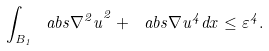<formula> <loc_0><loc_0><loc_500><loc_500>\int _ { B _ { 1 } } \ a b s { \nabla ^ { 2 } u } ^ { 2 } + \ a b s { \nabla u } ^ { 4 } d x \leq \varepsilon ^ { 4 } .</formula> 